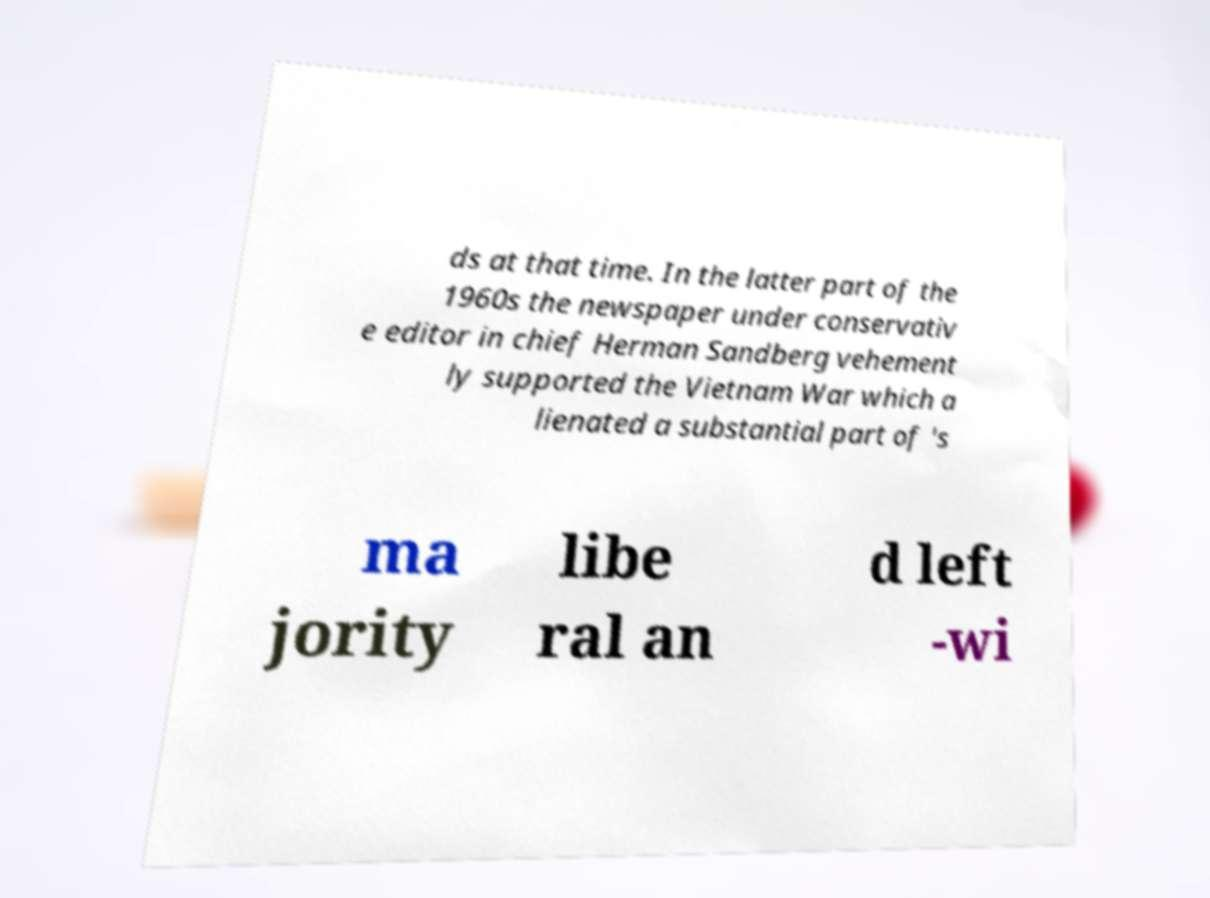Could you assist in decoding the text presented in this image and type it out clearly? ds at that time. In the latter part of the 1960s the newspaper under conservativ e editor in chief Herman Sandberg vehement ly supported the Vietnam War which a lienated a substantial part of 's ma jority libe ral an d left -wi 